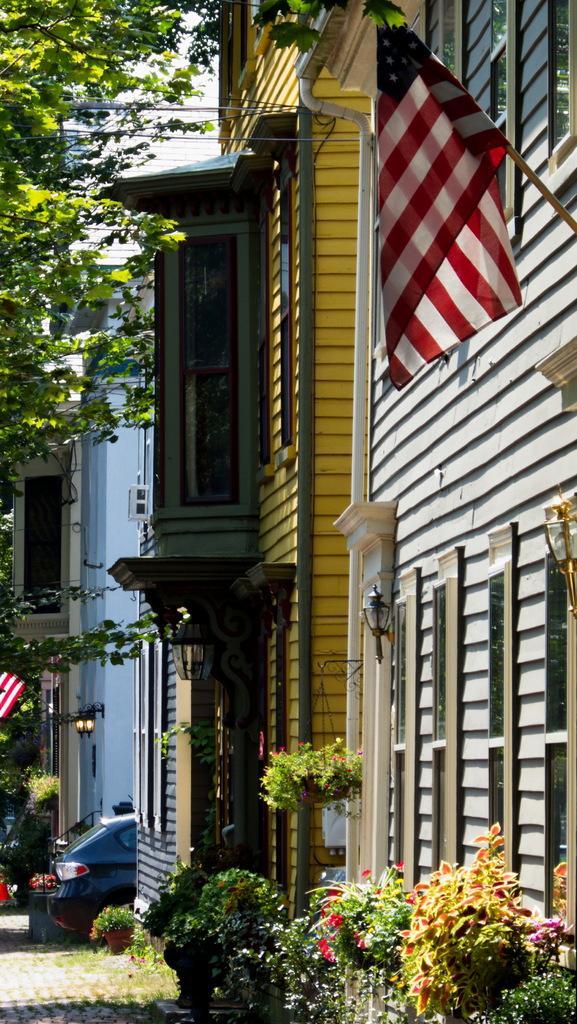Can you describe this image briefly? In the center of the image we can see buildings, branches with leaves, plants, lamps, one vehicle and a few other objects. 